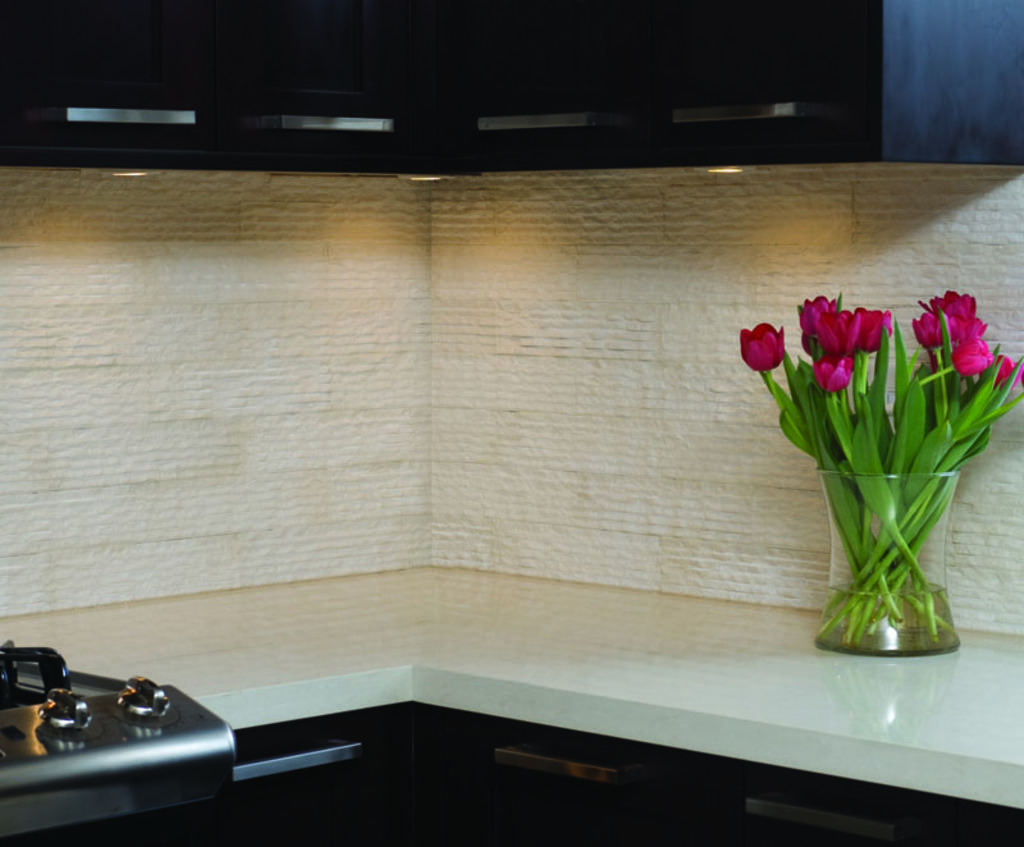Could you give a brief overview of what you see in this image? In this picture we can see flowers in a glass vase on the platform, wall and black object. In the background of the image it is dark. 